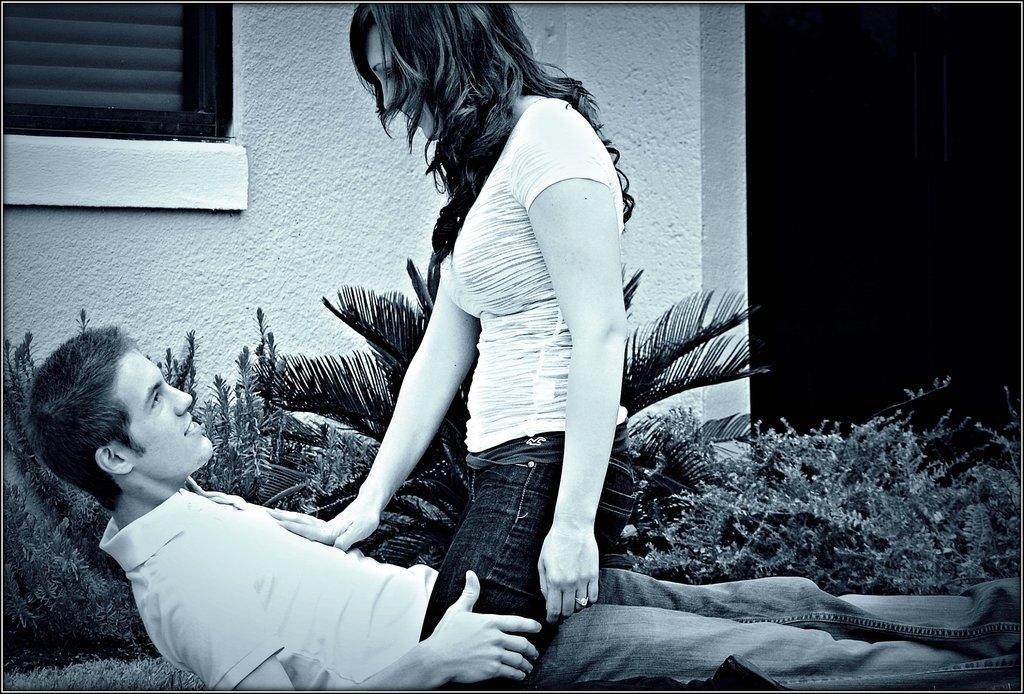Describe this image in one or two sentences. Here a man is lying, he wore a t-shirt. A girl is standing over him, she wore t-shirt, these are the plants and this is a wall. 